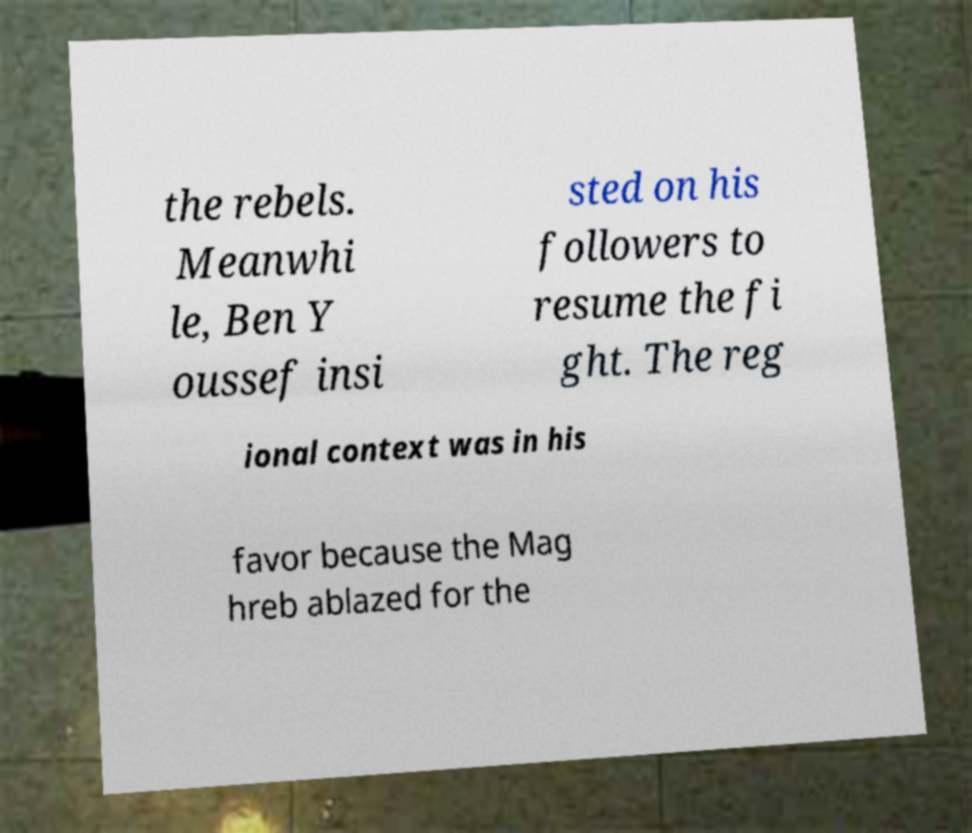Could you assist in decoding the text presented in this image and type it out clearly? the rebels. Meanwhi le, Ben Y oussef insi sted on his followers to resume the fi ght. The reg ional context was in his favor because the Mag hreb ablazed for the 